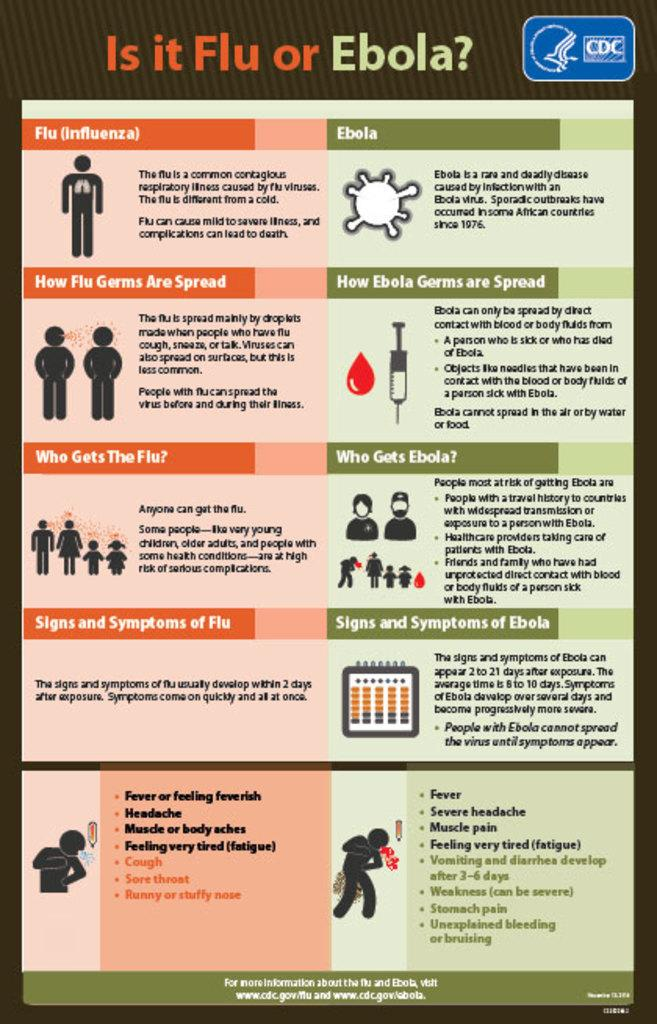<image>
Write a terse but informative summary of the picture. a poster educating people on the flu vs ebola 